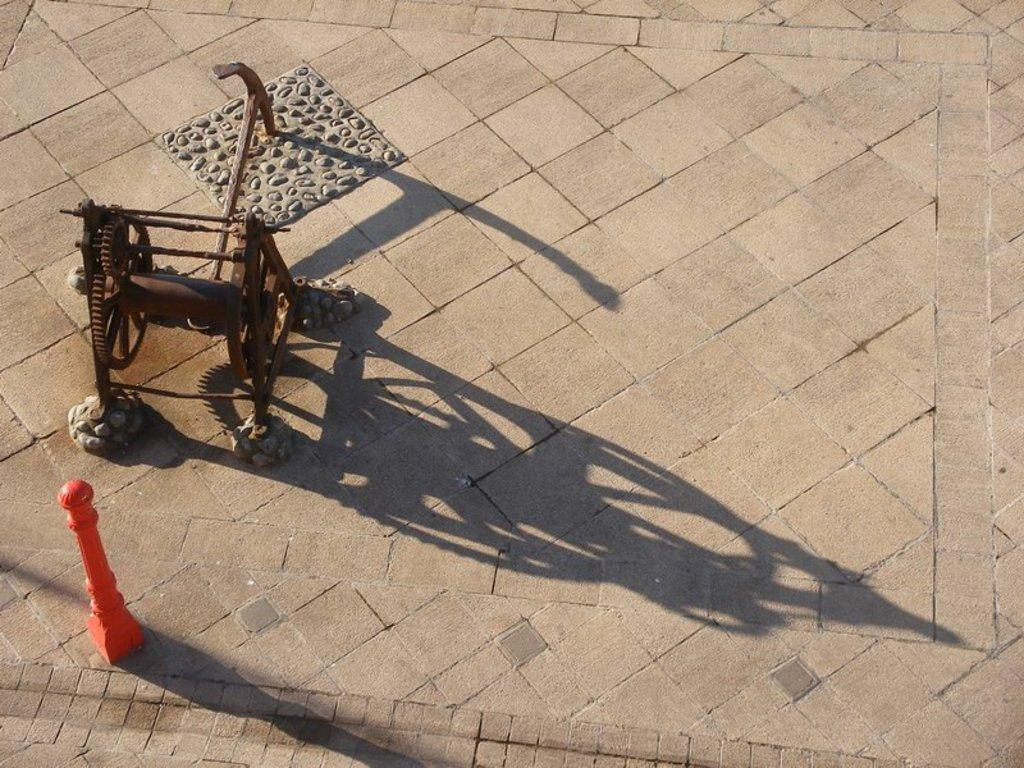What is the color of the floor in the image? The floor in the image is cream-colored. What object is placed on the floor? There is an object on the cream-colored floor. What is the color of the other object on the floor? There is a red-colored object on the floor. How many yams are being held by the son in the image? There is no son or yams present in the image. What type of books can be seen on the floor in the image? There are no books present in the image. 